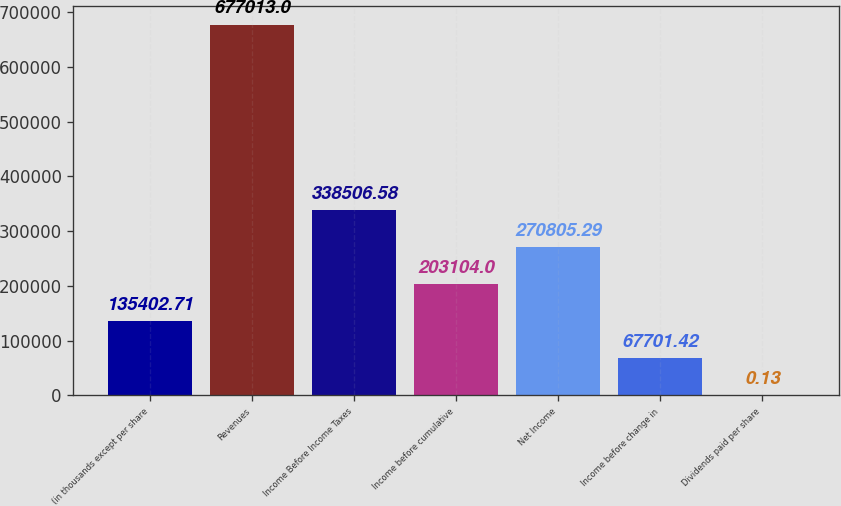Convert chart. <chart><loc_0><loc_0><loc_500><loc_500><bar_chart><fcel>(in thousands except per share<fcel>Revenues<fcel>Income Before Income Taxes<fcel>Income before cumulative<fcel>Net Income<fcel>Income before change in<fcel>Dividends paid per share<nl><fcel>135403<fcel>677013<fcel>338507<fcel>203104<fcel>270805<fcel>67701.4<fcel>0.13<nl></chart> 